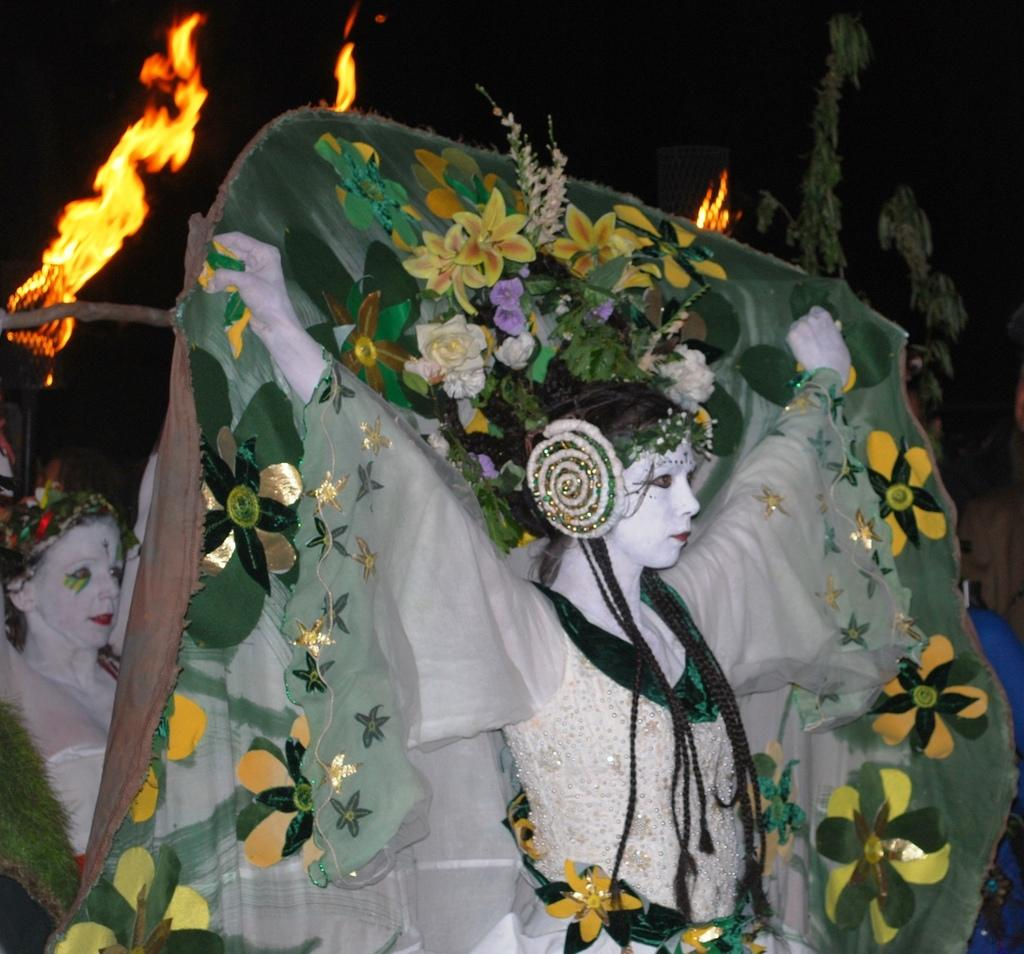Who or what can be seen in the image? There are people in the image. What are the people wearing? The people are wearing costumes. What can be seen in the background of the image? There is fire and leaves visible in the background of the image. How would you describe the lighting in the background of the image? The background view is dark. What type of ornament is hanging from the mask in the image? There is no mask or ornament present in the image. 